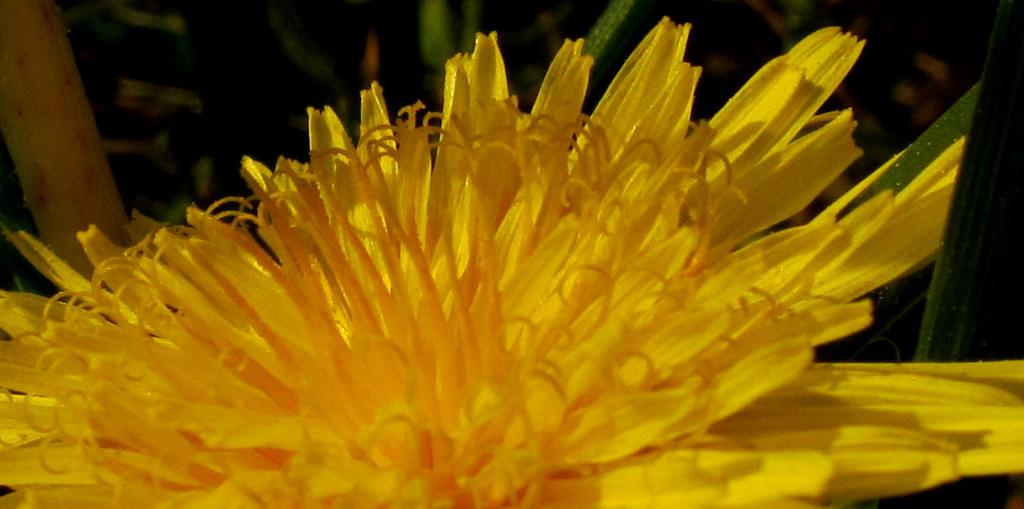What type of flower is present in the image? There is a yellow color flower in the image. How long does it take for the flower to roll across the room in the image? The flower does not roll across the room in the image; it is stationary. 